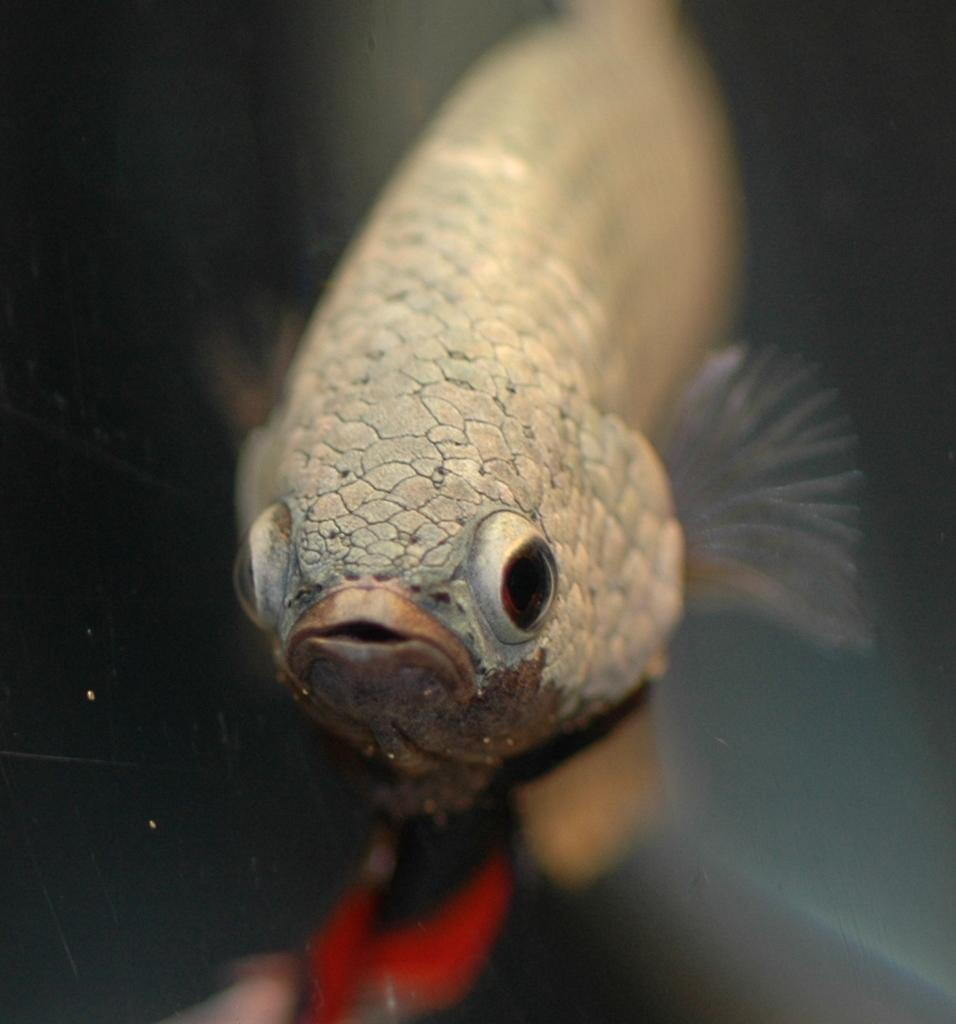What is the main subject of the image? There is a fish in the image. What is the fish doing in the image? The fish is swimming in the water. What color is the fish in the image? The fish is brown in color. Can you see the fish kissing another fish in the image? There is no indication of the fish kissing another fish in the image. 